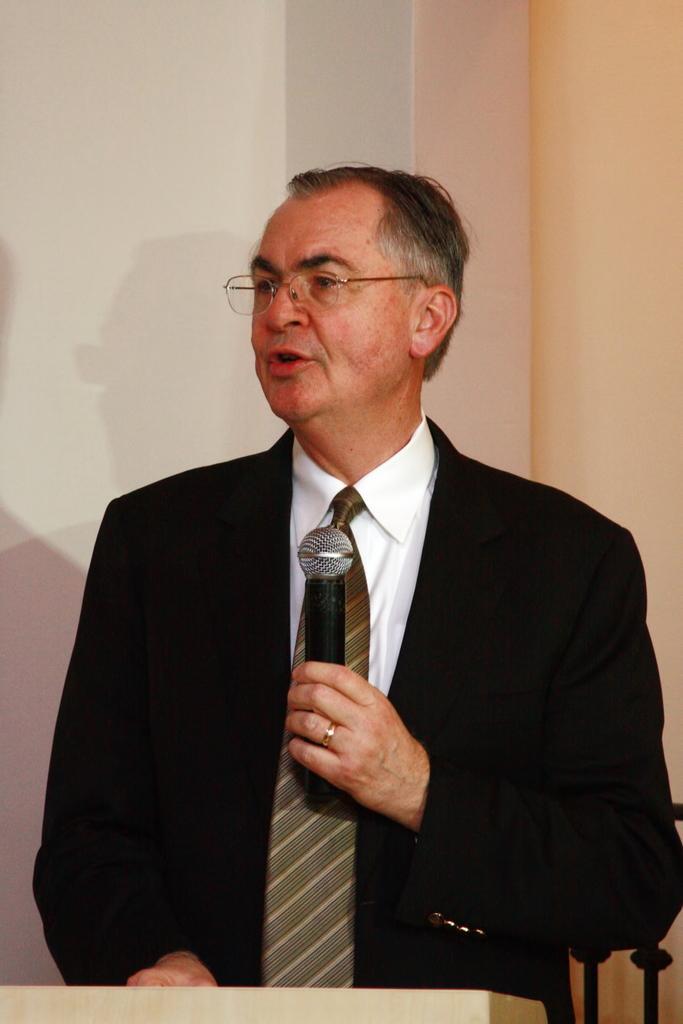How would you summarize this image in a sentence or two? As we can see in the image there is a man holding mic. 